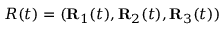<formula> <loc_0><loc_0><loc_500><loc_500>R ( t ) = ( { R } _ { 1 } ( t ) , { R } _ { 2 } ( t ) , { R } _ { 3 } ( t ) )</formula> 